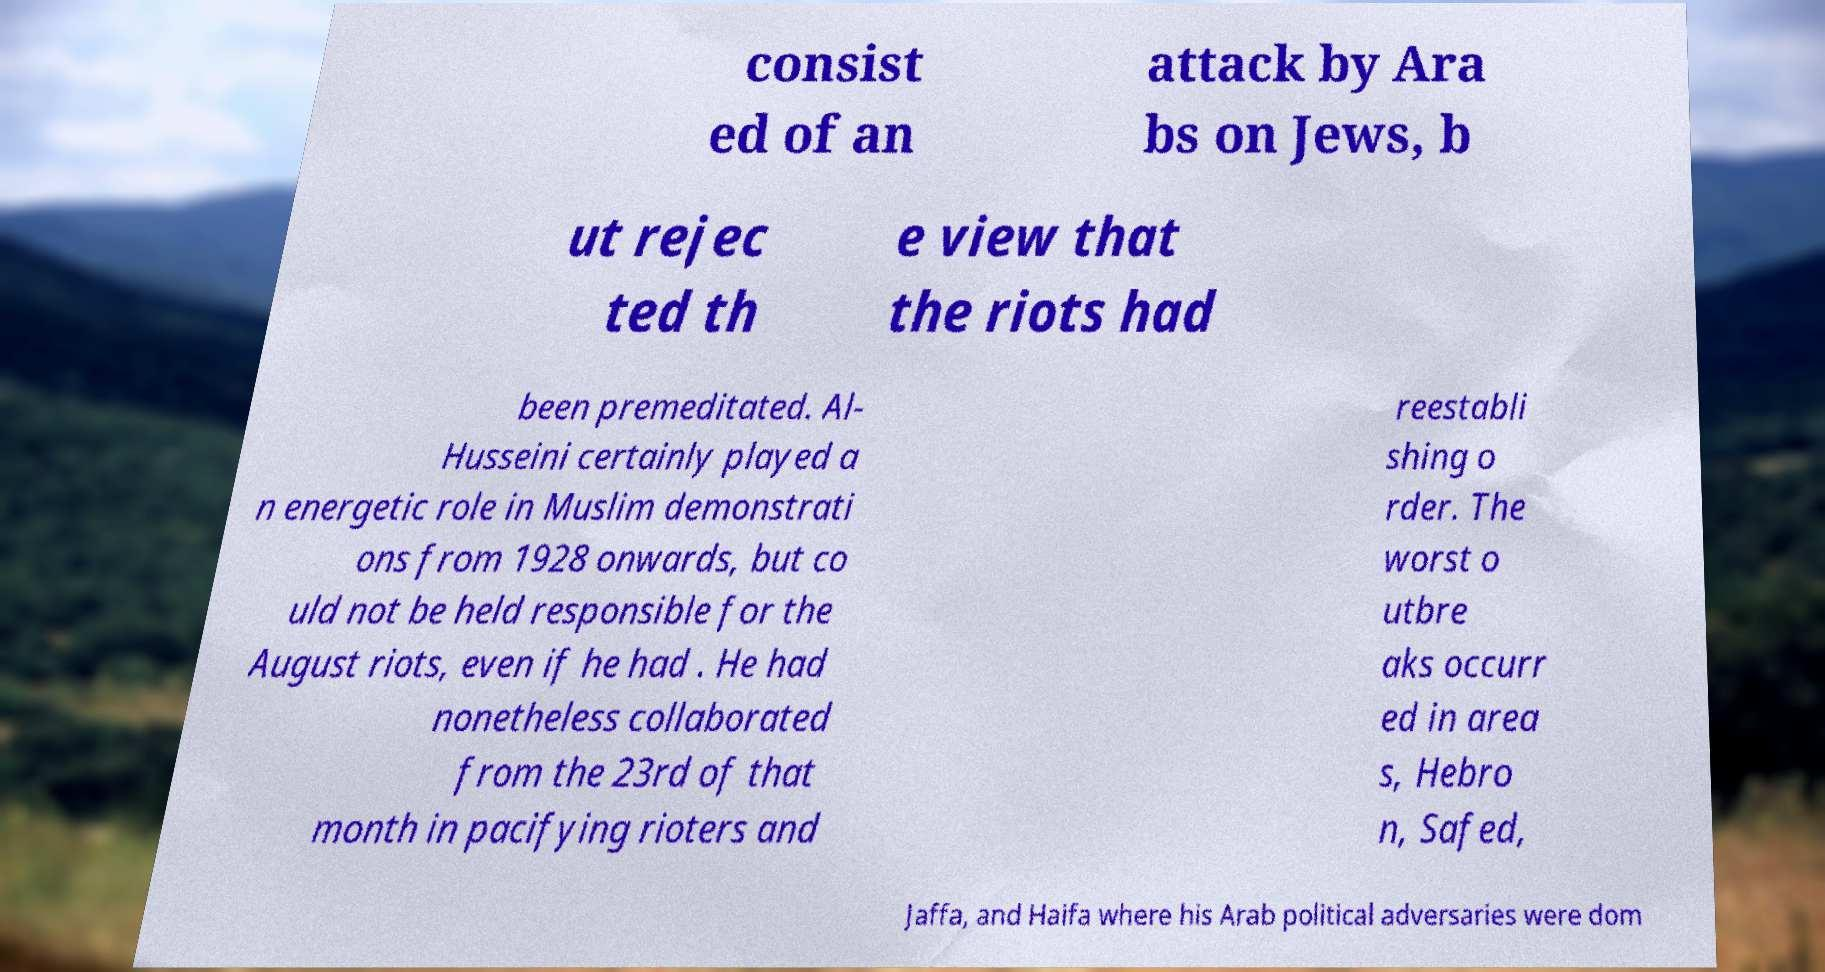I need the written content from this picture converted into text. Can you do that? consist ed of an attack by Ara bs on Jews, b ut rejec ted th e view that the riots had been premeditated. Al- Husseini certainly played a n energetic role in Muslim demonstrati ons from 1928 onwards, but co uld not be held responsible for the August riots, even if he had . He had nonetheless collaborated from the 23rd of that month in pacifying rioters and reestabli shing o rder. The worst o utbre aks occurr ed in area s, Hebro n, Safed, Jaffa, and Haifa where his Arab political adversaries were dom 